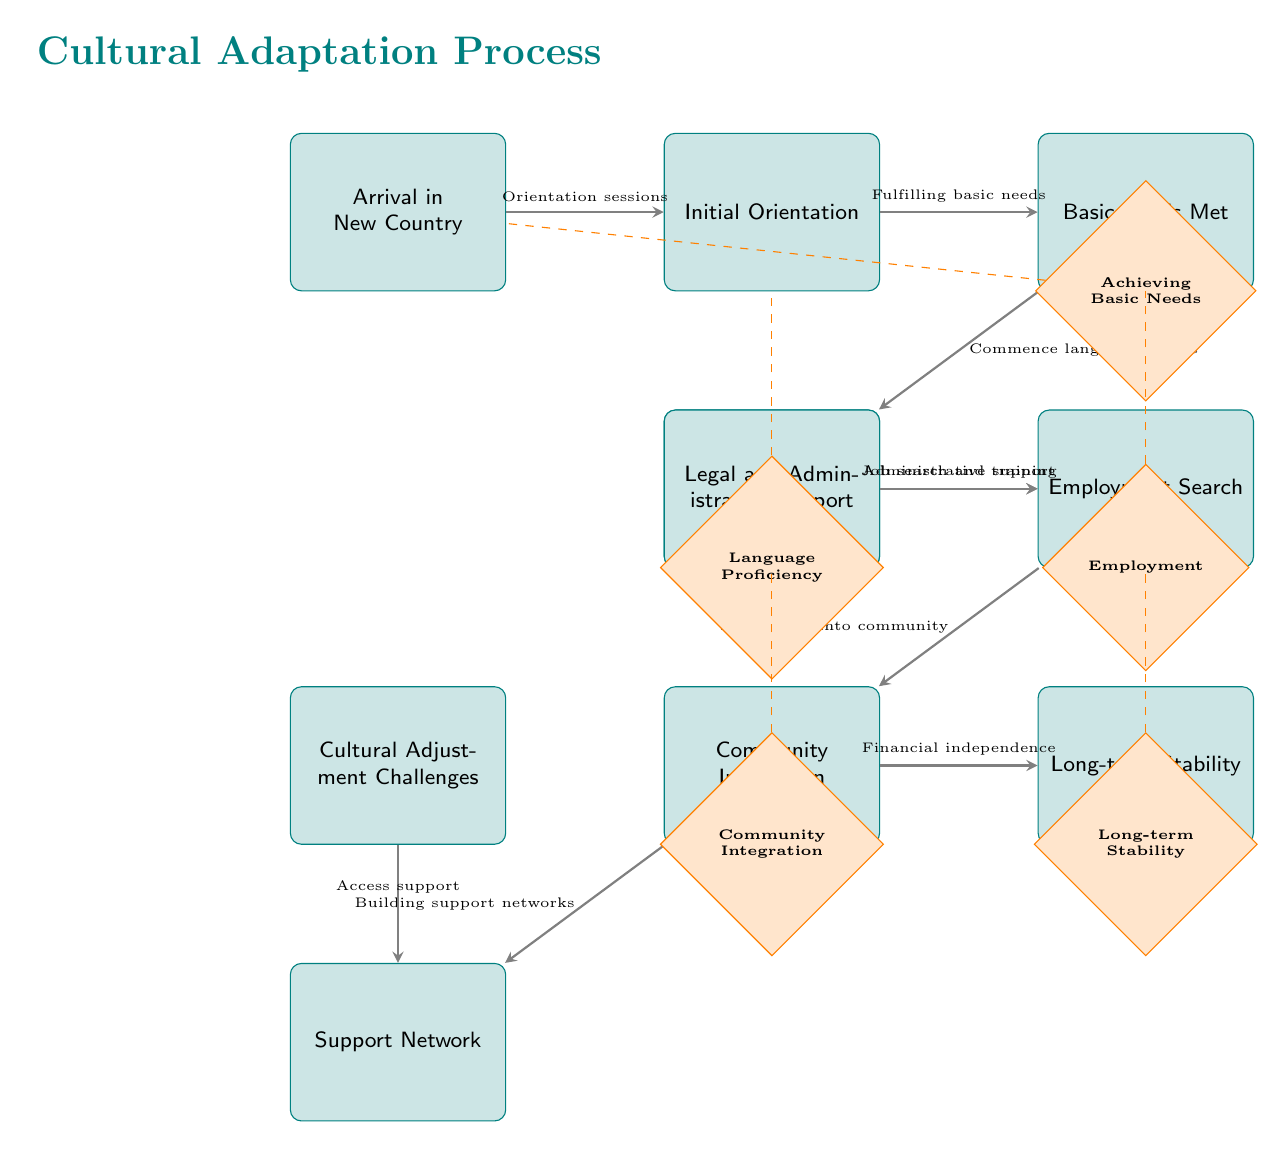What is the first step in the Cultural Adaptation Process? The first step in the diagram is labeled "Arrival in New Country." It is the starting node from which all subsequent steps flow.
Answer: Arrival in New Country How many milestones are there in the diagram? The diagram shows a total of five milestones represented as diamond-shaped nodes below certain boxes. They are labeled for achievements at various stages in the adaptation process.
Answer: 5 Which box is connected to "Language Proficiency"? The box labeled "Language Proficiency" is connected to the node "Basic Needs Met" through a dashed line, indicating it is a milestone that follows the language acquisition step.
Answer: Basic Needs Met What leads to "Community Integration"? The node "Community Integration" follows two pathways: one from "Employment Search" and one branching from the noun "Building support networks," indicating that both components are essential for integration into the community.
Answer: Employment Search and Building support networks What type of support is provided at the "Legal and Administrative Support" node? The "Legal and Administrative Support" is an essential step as it assists individuals in navigating legal aspects and fulfilling administrative requirements necessary for a settled life.
Answer: Administrative support What is the last milestone achieved in this adaptation flow? The last milestone in the flowchart is "Long-term Stability," which signifies the final goal after the previous steps have been processed successfully in the adaptation sequence.
Answer: Long-term Stability 